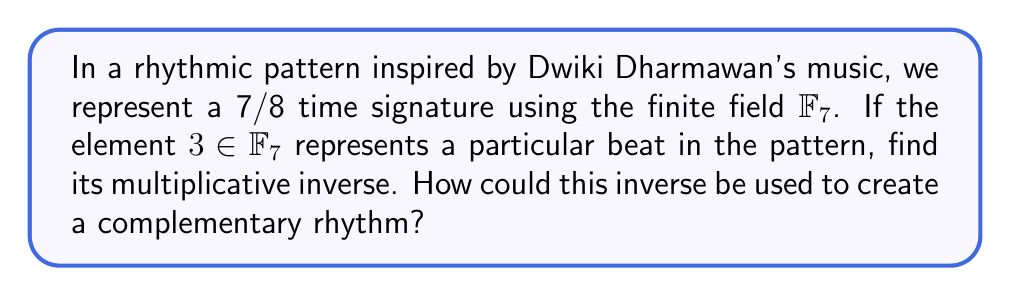Provide a solution to this math problem. 1) In the finite field $\mathbb{F}_7$, we need to find an element $x$ such that $3x \equiv 1 \pmod{7}$.

2) We can use the extended Euclidean algorithm:
   $7 = 2 \cdot 3 + 1$
   $3 = 3 \cdot 1 + 0$

3) Working backwards:
   $1 = 7 - 2 \cdot 3$
   $1 \equiv -2 \cdot 3 \pmod{7}$
   $1 \equiv 5 \cdot 3 \pmod{7}$

4) Therefore, the multiplicative inverse of 3 in $\mathbb{F}_7$ is 5.

5) In terms of rhythm, if 3 represents a beat on the third eighth note, its inverse (5) would represent a beat on the fifth eighth note. This creates a complementary rhythm that, when combined with the original, spans the entire measure:

   Original:    $\bullet \circ \bullet \circ \circ \circ \circ$
   Complement:  $\circ \circ \circ \circ \bullet \circ \circ$
   Combined:    $\bullet \circ \bullet \circ \bullet \circ \circ$

This complementary rhythm technique could be used in songwriting to create interesting polyrhythms or call-and-response patterns, reminiscent of the complex rhythmic structures often found in Dwiki Dharmawan's fusion of traditional Indonesian and jazz music.
Answer: $5$ 